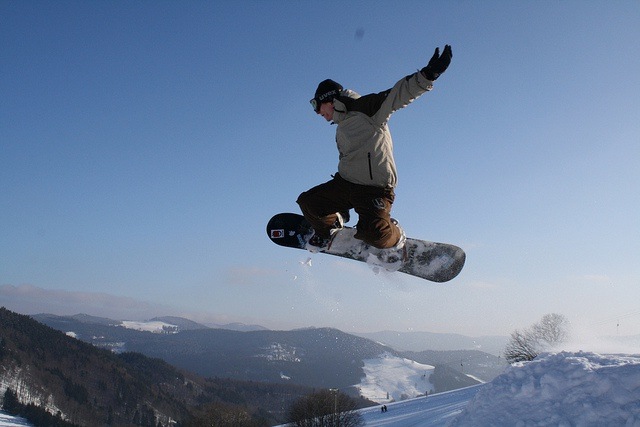Describe the objects in this image and their specific colors. I can see people in blue, black, gray, darkgray, and maroon tones, snowboard in blue, gray, black, and darkgray tones, and people in blue, black, navy, and gray tones in this image. 